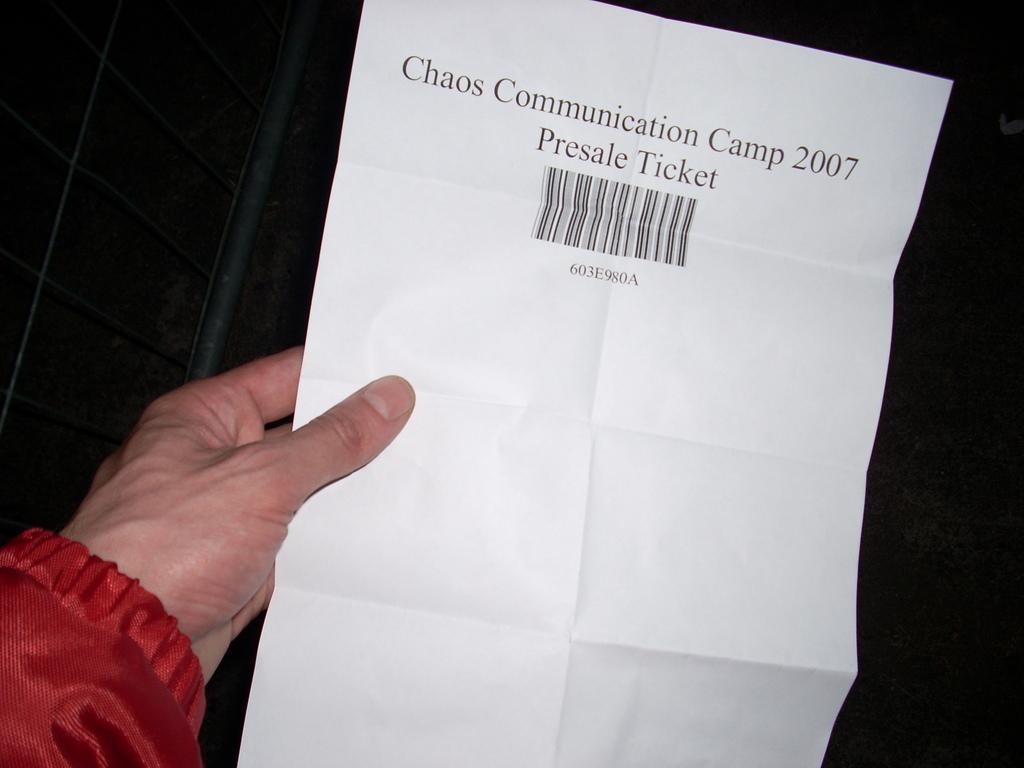Can you describe this image briefly? In this picture I can see a human hand holding a paper with some text and a barcode on the paper and I can see a black background. 